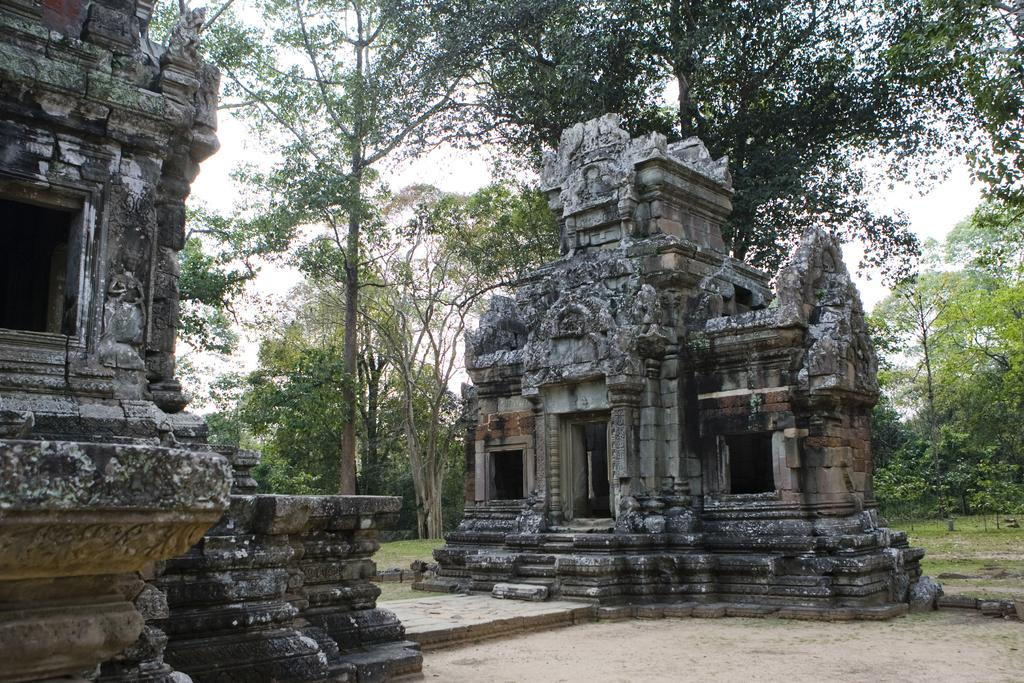What type of artwork can be seen in the image? There are sculptures in the image. What type of vegetation is present in the image? There are trees, plants, and grass in the image. What type of apparatus is being used by the sculptures in the image? There is no apparatus being used by the sculptures in the image; they are stationary art pieces. 